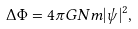Convert formula to latex. <formula><loc_0><loc_0><loc_500><loc_500>\Delta \Phi = 4 \pi G N m | \psi | ^ { 2 } ,</formula> 